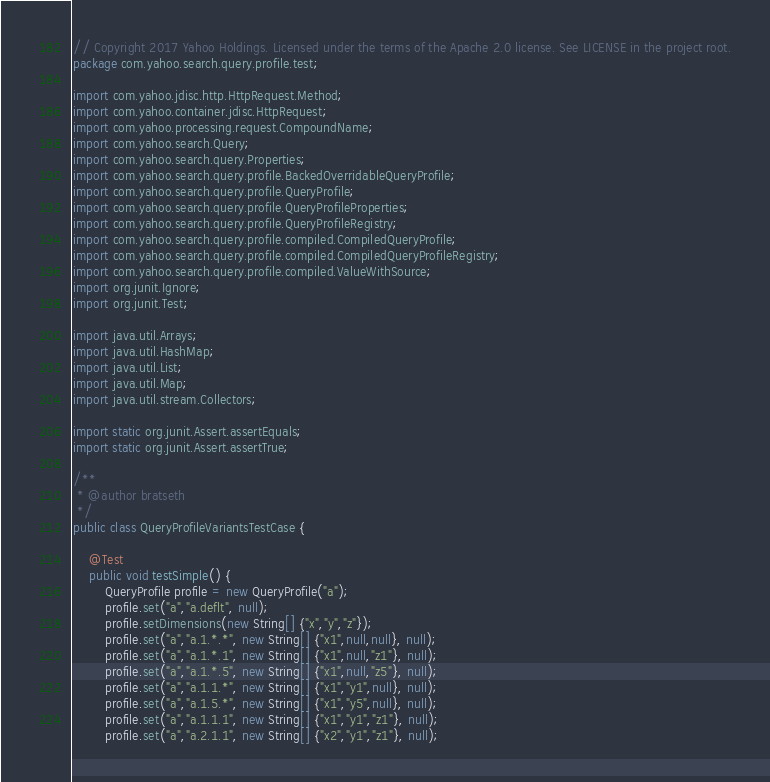<code> <loc_0><loc_0><loc_500><loc_500><_Java_>// Copyright 2017 Yahoo Holdings. Licensed under the terms of the Apache 2.0 license. See LICENSE in the project root.
package com.yahoo.search.query.profile.test;

import com.yahoo.jdisc.http.HttpRequest.Method;
import com.yahoo.container.jdisc.HttpRequest;
import com.yahoo.processing.request.CompoundName;
import com.yahoo.search.Query;
import com.yahoo.search.query.Properties;
import com.yahoo.search.query.profile.BackedOverridableQueryProfile;
import com.yahoo.search.query.profile.QueryProfile;
import com.yahoo.search.query.profile.QueryProfileProperties;
import com.yahoo.search.query.profile.QueryProfileRegistry;
import com.yahoo.search.query.profile.compiled.CompiledQueryProfile;
import com.yahoo.search.query.profile.compiled.CompiledQueryProfileRegistry;
import com.yahoo.search.query.profile.compiled.ValueWithSource;
import org.junit.Ignore;
import org.junit.Test;

import java.util.Arrays;
import java.util.HashMap;
import java.util.List;
import java.util.Map;
import java.util.stream.Collectors;

import static org.junit.Assert.assertEquals;
import static org.junit.Assert.assertTrue;

/**
 * @author bratseth
 */
public class QueryProfileVariantsTestCase {

    @Test
    public void testSimple() {
        QueryProfile profile = new QueryProfile("a");
        profile.set("a","a.deflt", null);
        profile.setDimensions(new String[] {"x","y","z"});
        profile.set("a","a.1.*.*", new String[] {"x1",null,null}, null);
        profile.set("a","a.1.*.1", new String[] {"x1",null,"z1"}, null);
        profile.set("a","a.1.*.5", new String[] {"x1",null,"z5"}, null);
        profile.set("a","a.1.1.*", new String[] {"x1","y1",null}, null);
        profile.set("a","a.1.5.*", new String[] {"x1","y5",null}, null);
        profile.set("a","a.1.1.1", new String[] {"x1","y1","z1"}, null);
        profile.set("a","a.2.1.1", new String[] {"x2","y1","z1"}, null);</code> 